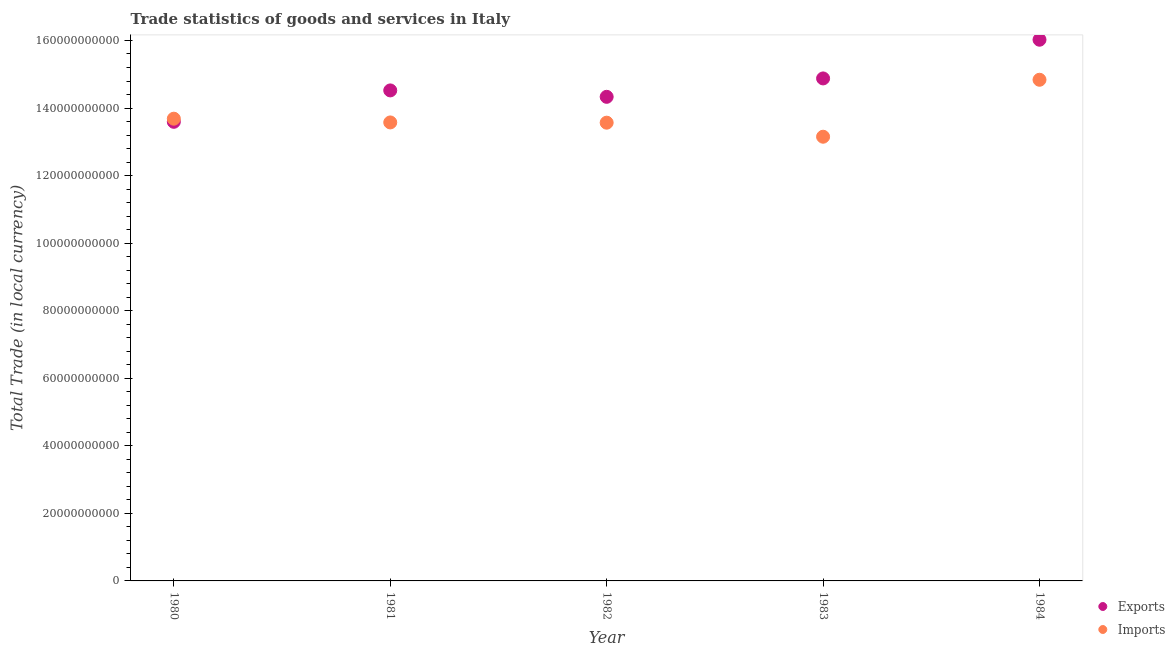How many different coloured dotlines are there?
Your answer should be very brief. 2. Is the number of dotlines equal to the number of legend labels?
Give a very brief answer. Yes. What is the export of goods and services in 1980?
Make the answer very short. 1.36e+11. Across all years, what is the maximum export of goods and services?
Keep it short and to the point. 1.60e+11. Across all years, what is the minimum export of goods and services?
Offer a very short reply. 1.36e+11. In which year was the imports of goods and services minimum?
Your answer should be compact. 1983. What is the total imports of goods and services in the graph?
Your answer should be compact. 6.88e+11. What is the difference between the imports of goods and services in 1980 and that in 1982?
Offer a terse response. 1.18e+09. What is the difference between the imports of goods and services in 1980 and the export of goods and services in 1984?
Your answer should be very brief. -2.34e+1. What is the average export of goods and services per year?
Your response must be concise. 1.47e+11. In the year 1984, what is the difference between the export of goods and services and imports of goods and services?
Provide a succinct answer. 1.19e+1. In how many years, is the export of goods and services greater than 144000000000 LCU?
Offer a very short reply. 3. What is the ratio of the export of goods and services in 1983 to that in 1984?
Your answer should be very brief. 0.93. Is the export of goods and services in 1982 less than that in 1984?
Ensure brevity in your answer.  Yes. What is the difference between the highest and the second highest export of goods and services?
Your answer should be compact. 1.15e+1. What is the difference between the highest and the lowest imports of goods and services?
Your answer should be very brief. 1.69e+1. In how many years, is the export of goods and services greater than the average export of goods and services taken over all years?
Offer a very short reply. 2. Is the imports of goods and services strictly greater than the export of goods and services over the years?
Your answer should be compact. No. How many dotlines are there?
Offer a very short reply. 2. Where does the legend appear in the graph?
Ensure brevity in your answer.  Bottom right. How many legend labels are there?
Offer a terse response. 2. How are the legend labels stacked?
Make the answer very short. Vertical. What is the title of the graph?
Offer a very short reply. Trade statistics of goods and services in Italy. What is the label or title of the Y-axis?
Ensure brevity in your answer.  Total Trade (in local currency). What is the Total Trade (in local currency) of Exports in 1980?
Give a very brief answer. 1.36e+11. What is the Total Trade (in local currency) of Imports in 1980?
Offer a terse response. 1.37e+11. What is the Total Trade (in local currency) in Exports in 1981?
Offer a very short reply. 1.45e+11. What is the Total Trade (in local currency) in Imports in 1981?
Your response must be concise. 1.36e+11. What is the Total Trade (in local currency) of Exports in 1982?
Your answer should be compact. 1.43e+11. What is the Total Trade (in local currency) of Imports in 1982?
Your response must be concise. 1.36e+11. What is the Total Trade (in local currency) of Exports in 1983?
Keep it short and to the point. 1.49e+11. What is the Total Trade (in local currency) in Imports in 1983?
Provide a succinct answer. 1.32e+11. What is the Total Trade (in local currency) of Exports in 1984?
Provide a succinct answer. 1.60e+11. What is the Total Trade (in local currency) in Imports in 1984?
Make the answer very short. 1.48e+11. Across all years, what is the maximum Total Trade (in local currency) of Exports?
Make the answer very short. 1.60e+11. Across all years, what is the maximum Total Trade (in local currency) of Imports?
Make the answer very short. 1.48e+11. Across all years, what is the minimum Total Trade (in local currency) in Exports?
Keep it short and to the point. 1.36e+11. Across all years, what is the minimum Total Trade (in local currency) of Imports?
Your response must be concise. 1.32e+11. What is the total Total Trade (in local currency) in Exports in the graph?
Keep it short and to the point. 7.33e+11. What is the total Total Trade (in local currency) of Imports in the graph?
Your response must be concise. 6.88e+11. What is the difference between the Total Trade (in local currency) in Exports in 1980 and that in 1981?
Provide a short and direct response. -9.29e+09. What is the difference between the Total Trade (in local currency) of Imports in 1980 and that in 1981?
Your answer should be very brief. 1.11e+09. What is the difference between the Total Trade (in local currency) in Exports in 1980 and that in 1982?
Offer a terse response. -7.40e+09. What is the difference between the Total Trade (in local currency) in Imports in 1980 and that in 1982?
Your answer should be very brief. 1.18e+09. What is the difference between the Total Trade (in local currency) in Exports in 1980 and that in 1983?
Offer a terse response. -1.28e+1. What is the difference between the Total Trade (in local currency) of Imports in 1980 and that in 1983?
Provide a short and direct response. 5.34e+09. What is the difference between the Total Trade (in local currency) of Exports in 1980 and that in 1984?
Your answer should be compact. -2.43e+1. What is the difference between the Total Trade (in local currency) of Imports in 1980 and that in 1984?
Make the answer very short. -1.15e+1. What is the difference between the Total Trade (in local currency) in Exports in 1981 and that in 1982?
Provide a short and direct response. 1.90e+09. What is the difference between the Total Trade (in local currency) in Imports in 1981 and that in 1982?
Your response must be concise. 7.37e+07. What is the difference between the Total Trade (in local currency) in Exports in 1981 and that in 1983?
Keep it short and to the point. -3.55e+09. What is the difference between the Total Trade (in local currency) in Imports in 1981 and that in 1983?
Offer a terse response. 4.23e+09. What is the difference between the Total Trade (in local currency) of Exports in 1981 and that in 1984?
Offer a terse response. -1.50e+1. What is the difference between the Total Trade (in local currency) of Imports in 1981 and that in 1984?
Your answer should be very brief. -1.26e+1. What is the difference between the Total Trade (in local currency) in Exports in 1982 and that in 1983?
Provide a short and direct response. -5.45e+09. What is the difference between the Total Trade (in local currency) in Imports in 1982 and that in 1983?
Make the answer very short. 4.16e+09. What is the difference between the Total Trade (in local currency) of Exports in 1982 and that in 1984?
Make the answer very short. -1.69e+1. What is the difference between the Total Trade (in local currency) in Imports in 1982 and that in 1984?
Offer a very short reply. -1.27e+1. What is the difference between the Total Trade (in local currency) in Exports in 1983 and that in 1984?
Your answer should be very brief. -1.15e+1. What is the difference between the Total Trade (in local currency) in Imports in 1983 and that in 1984?
Your response must be concise. -1.69e+1. What is the difference between the Total Trade (in local currency) of Exports in 1980 and the Total Trade (in local currency) of Imports in 1981?
Your answer should be compact. 1.83e+08. What is the difference between the Total Trade (in local currency) of Exports in 1980 and the Total Trade (in local currency) of Imports in 1982?
Ensure brevity in your answer.  2.57e+08. What is the difference between the Total Trade (in local currency) of Exports in 1980 and the Total Trade (in local currency) of Imports in 1983?
Your response must be concise. 4.41e+09. What is the difference between the Total Trade (in local currency) of Exports in 1980 and the Total Trade (in local currency) of Imports in 1984?
Ensure brevity in your answer.  -1.24e+1. What is the difference between the Total Trade (in local currency) of Exports in 1981 and the Total Trade (in local currency) of Imports in 1982?
Offer a very short reply. 9.55e+09. What is the difference between the Total Trade (in local currency) of Exports in 1981 and the Total Trade (in local currency) of Imports in 1983?
Provide a short and direct response. 1.37e+1. What is the difference between the Total Trade (in local currency) in Exports in 1981 and the Total Trade (in local currency) in Imports in 1984?
Provide a succinct answer. -3.15e+09. What is the difference between the Total Trade (in local currency) of Exports in 1982 and the Total Trade (in local currency) of Imports in 1983?
Provide a short and direct response. 1.18e+1. What is the difference between the Total Trade (in local currency) in Exports in 1982 and the Total Trade (in local currency) in Imports in 1984?
Give a very brief answer. -5.05e+09. What is the difference between the Total Trade (in local currency) in Exports in 1983 and the Total Trade (in local currency) in Imports in 1984?
Your answer should be compact. 3.96e+08. What is the average Total Trade (in local currency) in Exports per year?
Offer a very short reply. 1.47e+11. What is the average Total Trade (in local currency) in Imports per year?
Offer a terse response. 1.38e+11. In the year 1980, what is the difference between the Total Trade (in local currency) of Exports and Total Trade (in local currency) of Imports?
Offer a very short reply. -9.24e+08. In the year 1981, what is the difference between the Total Trade (in local currency) in Exports and Total Trade (in local currency) in Imports?
Offer a terse response. 9.48e+09. In the year 1982, what is the difference between the Total Trade (in local currency) of Exports and Total Trade (in local currency) of Imports?
Give a very brief answer. 7.65e+09. In the year 1983, what is the difference between the Total Trade (in local currency) in Exports and Total Trade (in local currency) in Imports?
Provide a succinct answer. 1.73e+1. In the year 1984, what is the difference between the Total Trade (in local currency) of Exports and Total Trade (in local currency) of Imports?
Your answer should be very brief. 1.19e+1. What is the ratio of the Total Trade (in local currency) of Exports in 1980 to that in 1981?
Keep it short and to the point. 0.94. What is the ratio of the Total Trade (in local currency) in Imports in 1980 to that in 1981?
Ensure brevity in your answer.  1.01. What is the ratio of the Total Trade (in local currency) in Exports in 1980 to that in 1982?
Your response must be concise. 0.95. What is the ratio of the Total Trade (in local currency) of Imports in 1980 to that in 1982?
Give a very brief answer. 1.01. What is the ratio of the Total Trade (in local currency) of Exports in 1980 to that in 1983?
Your response must be concise. 0.91. What is the ratio of the Total Trade (in local currency) in Imports in 1980 to that in 1983?
Offer a terse response. 1.04. What is the ratio of the Total Trade (in local currency) in Exports in 1980 to that in 1984?
Keep it short and to the point. 0.85. What is the ratio of the Total Trade (in local currency) in Imports in 1980 to that in 1984?
Make the answer very short. 0.92. What is the ratio of the Total Trade (in local currency) of Exports in 1981 to that in 1982?
Offer a terse response. 1.01. What is the ratio of the Total Trade (in local currency) in Imports in 1981 to that in 1982?
Your answer should be compact. 1. What is the ratio of the Total Trade (in local currency) in Exports in 1981 to that in 1983?
Ensure brevity in your answer.  0.98. What is the ratio of the Total Trade (in local currency) in Imports in 1981 to that in 1983?
Keep it short and to the point. 1.03. What is the ratio of the Total Trade (in local currency) of Exports in 1981 to that in 1984?
Provide a succinct answer. 0.91. What is the ratio of the Total Trade (in local currency) of Imports in 1981 to that in 1984?
Offer a very short reply. 0.91. What is the ratio of the Total Trade (in local currency) of Exports in 1982 to that in 1983?
Keep it short and to the point. 0.96. What is the ratio of the Total Trade (in local currency) of Imports in 1982 to that in 1983?
Your answer should be very brief. 1.03. What is the ratio of the Total Trade (in local currency) in Exports in 1982 to that in 1984?
Keep it short and to the point. 0.89. What is the ratio of the Total Trade (in local currency) of Imports in 1982 to that in 1984?
Ensure brevity in your answer.  0.91. What is the ratio of the Total Trade (in local currency) in Exports in 1983 to that in 1984?
Keep it short and to the point. 0.93. What is the ratio of the Total Trade (in local currency) of Imports in 1983 to that in 1984?
Provide a short and direct response. 0.89. What is the difference between the highest and the second highest Total Trade (in local currency) of Exports?
Give a very brief answer. 1.15e+1. What is the difference between the highest and the second highest Total Trade (in local currency) in Imports?
Provide a short and direct response. 1.15e+1. What is the difference between the highest and the lowest Total Trade (in local currency) of Exports?
Give a very brief answer. 2.43e+1. What is the difference between the highest and the lowest Total Trade (in local currency) in Imports?
Provide a short and direct response. 1.69e+1. 